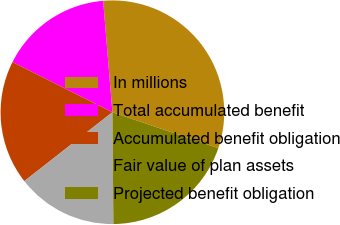Convert chart to OTSL. <chart><loc_0><loc_0><loc_500><loc_500><pie_chart><fcel>In millions<fcel>Total accumulated benefit<fcel>Accumulated benefit obligation<fcel>Fair value of plan assets<fcel>Projected benefit obligation<nl><fcel>31.52%<fcel>16.27%<fcel>17.97%<fcel>14.58%<fcel>19.66%<nl></chart> 